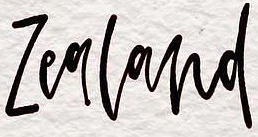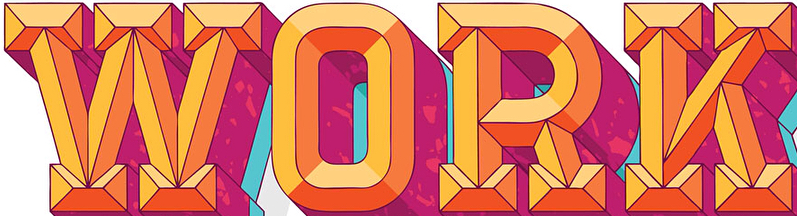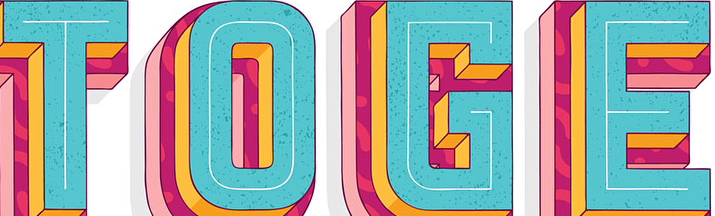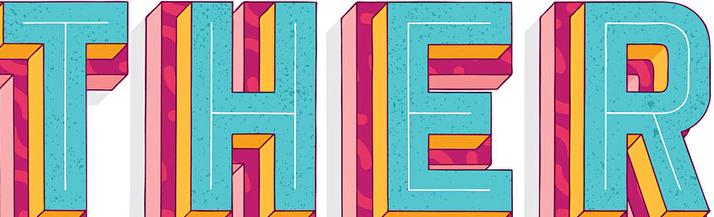Read the text content from these images in order, separated by a semicolon. Zealand; WORK; TOGE; THER 